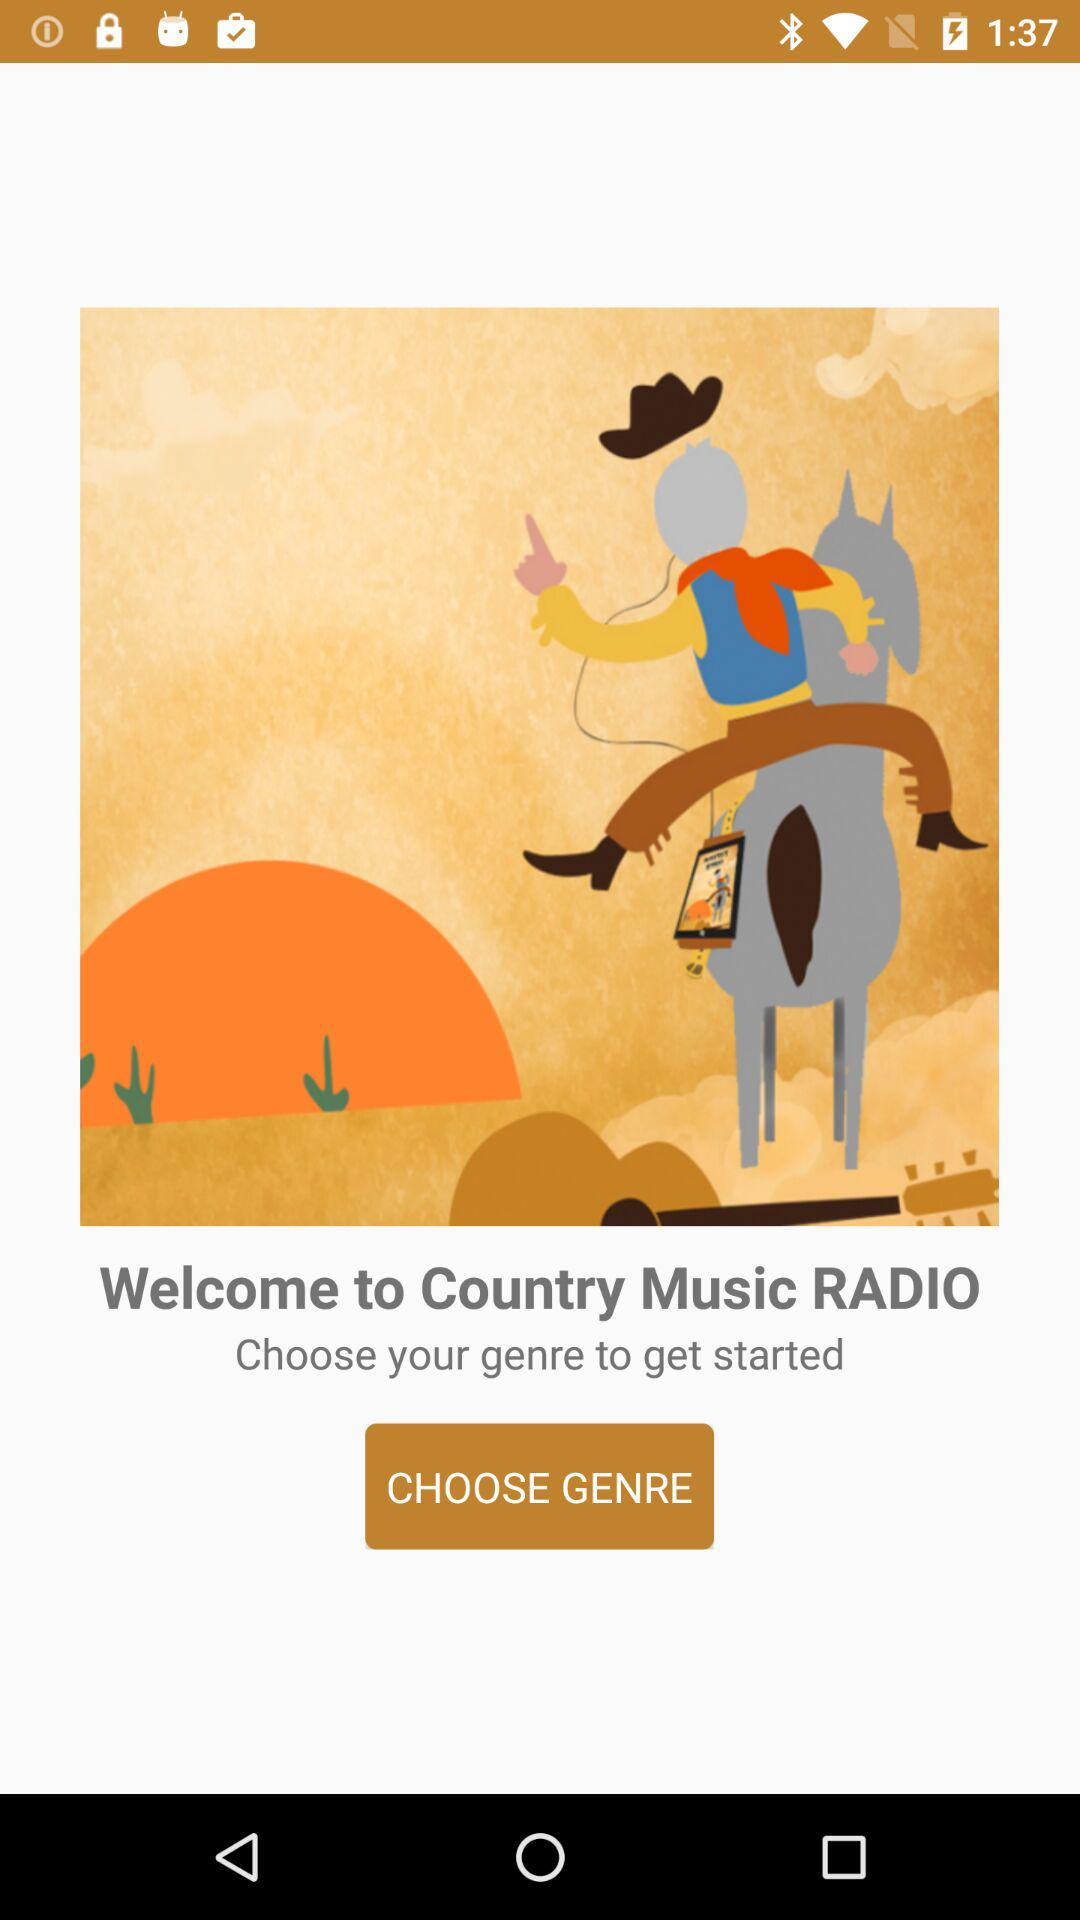What is the app name? The app name is "Country Music RADIO". 